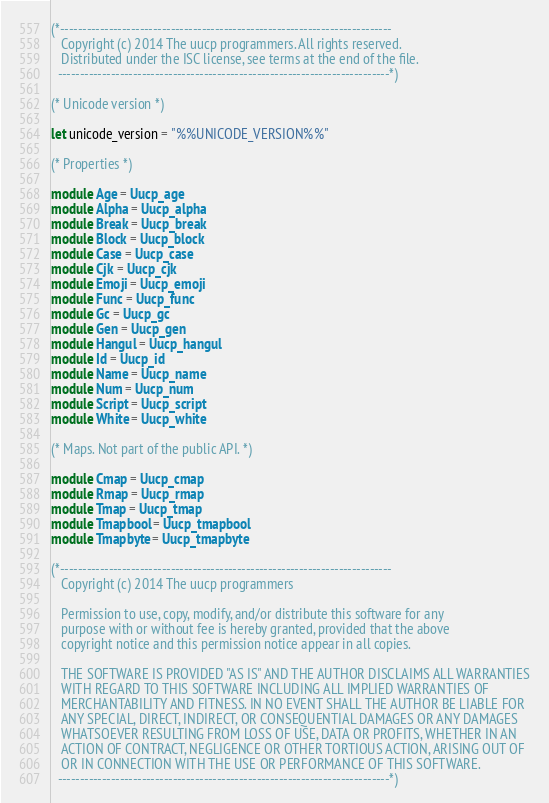<code> <loc_0><loc_0><loc_500><loc_500><_OCaml_>(*---------------------------------------------------------------------------
   Copyright (c) 2014 The uucp programmers. All rights reserved.
   Distributed under the ISC license, see terms at the end of the file.
  ---------------------------------------------------------------------------*)

(* Unicode version *)

let unicode_version = "%%UNICODE_VERSION%%"

(* Properties *)

module Age = Uucp_age
module Alpha = Uucp_alpha
module Break = Uucp_break
module Block = Uucp_block
module Case = Uucp_case
module Cjk = Uucp_cjk
module Emoji = Uucp_emoji
module Func = Uucp_func
module Gc = Uucp_gc
module Gen = Uucp_gen
module Hangul = Uucp_hangul
module Id = Uucp_id
module Name = Uucp_name
module Num = Uucp_num
module Script = Uucp_script
module White = Uucp_white

(* Maps. Not part of the public API. *)

module Cmap = Uucp_cmap
module Rmap = Uucp_rmap
module Tmap = Uucp_tmap
module Tmapbool = Uucp_tmapbool
module Tmapbyte = Uucp_tmapbyte

(*---------------------------------------------------------------------------
   Copyright (c) 2014 The uucp programmers

   Permission to use, copy, modify, and/or distribute this software for any
   purpose with or without fee is hereby granted, provided that the above
   copyright notice and this permission notice appear in all copies.

   THE SOFTWARE IS PROVIDED "AS IS" AND THE AUTHOR DISCLAIMS ALL WARRANTIES
   WITH REGARD TO THIS SOFTWARE INCLUDING ALL IMPLIED WARRANTIES OF
   MERCHANTABILITY AND FITNESS. IN NO EVENT SHALL THE AUTHOR BE LIABLE FOR
   ANY SPECIAL, DIRECT, INDIRECT, OR CONSEQUENTIAL DAMAGES OR ANY DAMAGES
   WHATSOEVER RESULTING FROM LOSS OF USE, DATA OR PROFITS, WHETHER IN AN
   ACTION OF CONTRACT, NEGLIGENCE OR OTHER TORTIOUS ACTION, ARISING OUT OF
   OR IN CONNECTION WITH THE USE OR PERFORMANCE OF THIS SOFTWARE.
  ---------------------------------------------------------------------------*)
</code> 